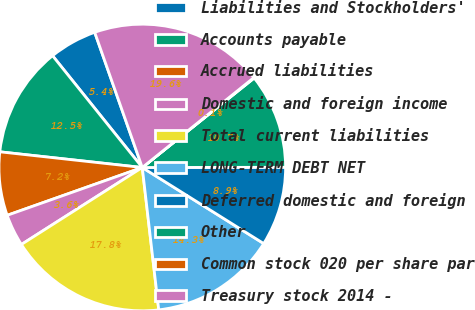<chart> <loc_0><loc_0><loc_500><loc_500><pie_chart><fcel>Liabilities and Stockholders'<fcel>Accounts payable<fcel>Accrued liabilities<fcel>Domestic and foreign income<fcel>Total current liabilities<fcel>LONG-TERM DEBT NET<fcel>Deferred domestic and foreign<fcel>Other<fcel>Common stock 020 per share par<fcel>Treasury stock 2014 -<nl><fcel>5.38%<fcel>12.49%<fcel>7.16%<fcel>3.61%<fcel>17.81%<fcel>14.26%<fcel>8.93%<fcel>10.71%<fcel>0.06%<fcel>19.59%<nl></chart> 